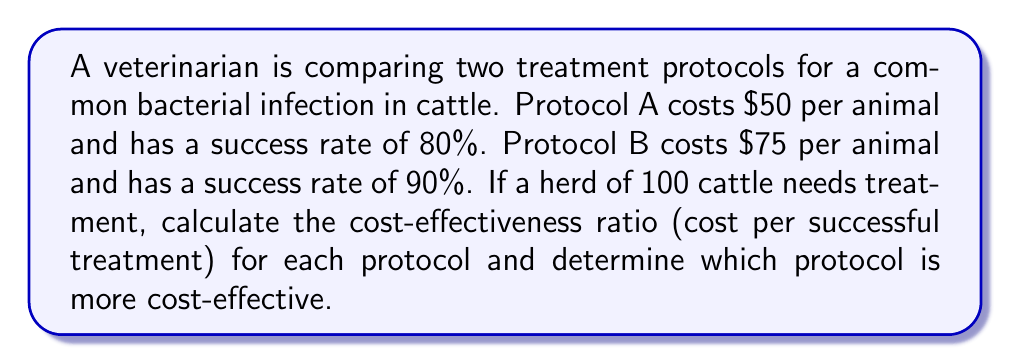Give your solution to this math problem. Let's approach this step-by-step:

1) First, let's calculate the total cost and number of successful treatments for each protocol:

   Protocol A:
   - Cost per animal: $50
   - Success rate: 80% = 0.8
   - Total cost: $50 × 100 = $5000
   - Number of successful treatments: 100 × 0.8 = 80

   Protocol B:
   - Cost per animal: $75
   - Success rate: 90% = 0.9
   - Total cost: $75 × 100 = $7500
   - Number of successful treatments: 100 × 0.9 = 90

2) Now, let's calculate the cost-effectiveness ratio for each protocol:

   Cost-effectiveness ratio = Total cost ÷ Number of successful treatments

   Protocol A:
   $$\text{Cost-effectiveness ratio A} = \frac{\$5000}{80} = \$62.50 \text{ per successful treatment}$$

   Protocol B:
   $$\text{Cost-effectiveness ratio B} = \frac{\$7500}{90} = \$83.33 \text{ per successful treatment}$$

3) Comparing the ratios:
   Protocol A costs $62.50 per successful treatment
   Protocol B costs $83.33 per successful treatment

Therefore, Protocol A is more cost-effective as it has a lower cost per successful treatment.
Answer: Protocol A at $62.50 per successful treatment 